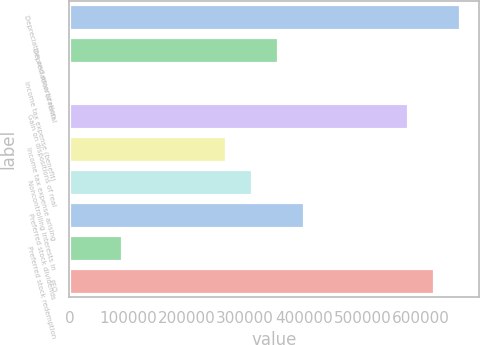Convert chart. <chart><loc_0><loc_0><loc_500><loc_500><bar_chart><fcel>Depreciation and amortization<fcel>Depreciation of rental<fcel>Income tax expense (benefit)<fcel>Gain on dispositions of real<fcel>Income tax expense arising<fcel>Noncontrolling interests in<fcel>Preferred stock dividends<fcel>Preferred stock redemption<fcel>FFO<nl><fcel>665828<fcel>355847<fcel>1582<fcel>577262<fcel>267281<fcel>311564<fcel>400130<fcel>90148.2<fcel>621545<nl></chart> 